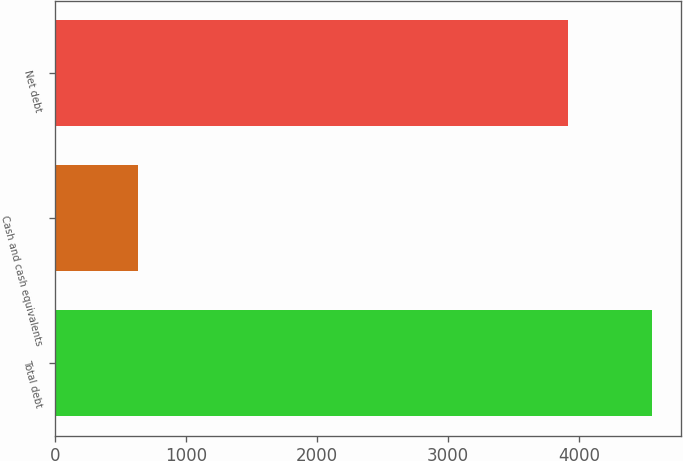Convert chart. <chart><loc_0><loc_0><loc_500><loc_500><bar_chart><fcel>Total debt<fcel>Cash and cash equivalents<fcel>Net debt<nl><fcel>4553.1<fcel>634.9<fcel>3918.2<nl></chart> 